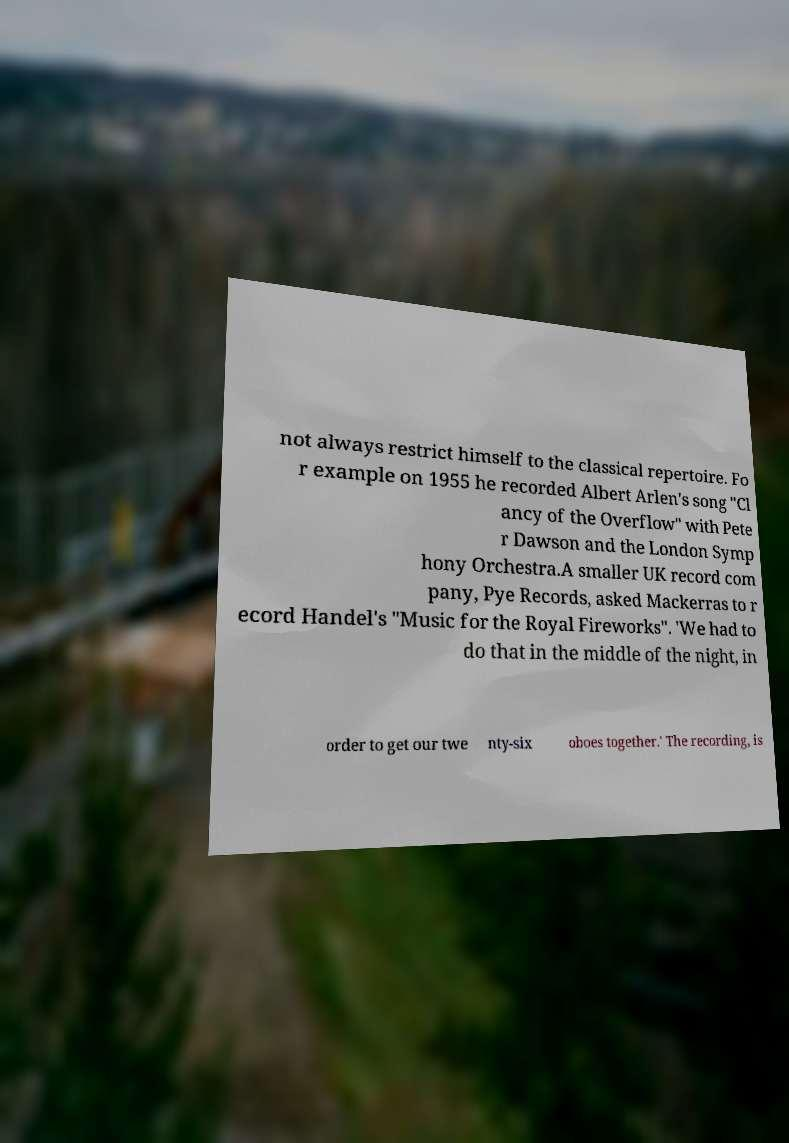What messages or text are displayed in this image? I need them in a readable, typed format. not always restrict himself to the classical repertoire. Fo r example on 1955 he recorded Albert Arlen's song "Cl ancy of the Overflow" with Pete r Dawson and the London Symp hony Orchestra.A smaller UK record com pany, Pye Records, asked Mackerras to r ecord Handel's "Music for the Royal Fireworks". 'We had to do that in the middle of the night, in order to get our twe nty-six oboes together.' The recording, is 